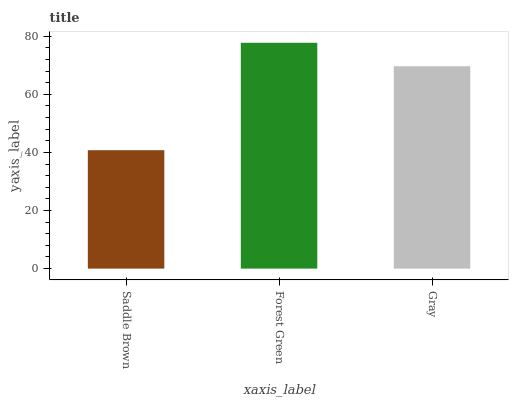Is Saddle Brown the minimum?
Answer yes or no. Yes. Is Forest Green the maximum?
Answer yes or no. Yes. Is Gray the minimum?
Answer yes or no. No. Is Gray the maximum?
Answer yes or no. No. Is Forest Green greater than Gray?
Answer yes or no. Yes. Is Gray less than Forest Green?
Answer yes or no. Yes. Is Gray greater than Forest Green?
Answer yes or no. No. Is Forest Green less than Gray?
Answer yes or no. No. Is Gray the high median?
Answer yes or no. Yes. Is Gray the low median?
Answer yes or no. Yes. Is Saddle Brown the high median?
Answer yes or no. No. Is Saddle Brown the low median?
Answer yes or no. No. 